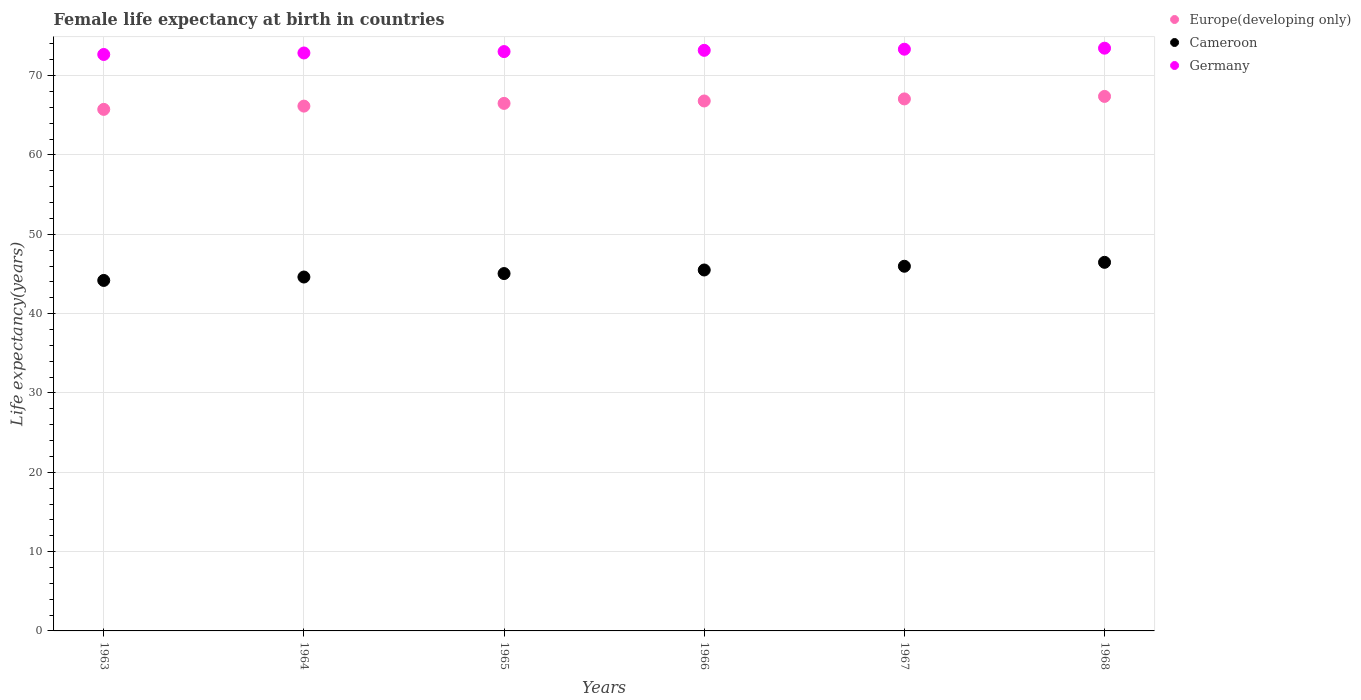Is the number of dotlines equal to the number of legend labels?
Provide a short and direct response. Yes. What is the female life expectancy at birth in Europe(developing only) in 1968?
Make the answer very short. 67.38. Across all years, what is the maximum female life expectancy at birth in Europe(developing only)?
Keep it short and to the point. 67.38. Across all years, what is the minimum female life expectancy at birth in Cameroon?
Give a very brief answer. 44.19. In which year was the female life expectancy at birth in Germany maximum?
Your response must be concise. 1968. In which year was the female life expectancy at birth in Europe(developing only) minimum?
Provide a short and direct response. 1963. What is the total female life expectancy at birth in Europe(developing only) in the graph?
Provide a succinct answer. 399.68. What is the difference between the female life expectancy at birth in Cameroon in 1966 and that in 1968?
Make the answer very short. -0.97. What is the difference between the female life expectancy at birth in Europe(developing only) in 1967 and the female life expectancy at birth in Germany in 1968?
Give a very brief answer. -6.39. What is the average female life expectancy at birth in Germany per year?
Ensure brevity in your answer.  73.09. In the year 1968, what is the difference between the female life expectancy at birth in Cameroon and female life expectancy at birth in Europe(developing only)?
Your answer should be very brief. -20.92. What is the ratio of the female life expectancy at birth in Europe(developing only) in 1963 to that in 1964?
Provide a succinct answer. 0.99. Is the difference between the female life expectancy at birth in Cameroon in 1966 and 1967 greater than the difference between the female life expectancy at birth in Europe(developing only) in 1966 and 1967?
Ensure brevity in your answer.  No. What is the difference between the highest and the second highest female life expectancy at birth in Germany?
Make the answer very short. 0.13. What is the difference between the highest and the lowest female life expectancy at birth in Germany?
Ensure brevity in your answer.  0.79. In how many years, is the female life expectancy at birth in Europe(developing only) greater than the average female life expectancy at birth in Europe(developing only) taken over all years?
Your answer should be very brief. 3. Is the sum of the female life expectancy at birth in Germany in 1963 and 1967 greater than the maximum female life expectancy at birth in Cameroon across all years?
Your response must be concise. Yes. Is the female life expectancy at birth in Germany strictly less than the female life expectancy at birth in Cameroon over the years?
Provide a short and direct response. No. How many dotlines are there?
Keep it short and to the point. 3. How many years are there in the graph?
Keep it short and to the point. 6. What is the difference between two consecutive major ticks on the Y-axis?
Offer a terse response. 10. Does the graph contain any zero values?
Provide a short and direct response. No. Does the graph contain grids?
Keep it short and to the point. Yes. Where does the legend appear in the graph?
Provide a short and direct response. Top right. What is the title of the graph?
Offer a terse response. Female life expectancy at birth in countries. What is the label or title of the Y-axis?
Offer a very short reply. Life expectancy(years). What is the Life expectancy(years) of Europe(developing only) in 1963?
Your answer should be very brief. 65.75. What is the Life expectancy(years) of Cameroon in 1963?
Your answer should be very brief. 44.19. What is the Life expectancy(years) in Germany in 1963?
Your answer should be compact. 72.67. What is the Life expectancy(years) of Europe(developing only) in 1964?
Give a very brief answer. 66.16. What is the Life expectancy(years) of Cameroon in 1964?
Give a very brief answer. 44.62. What is the Life expectancy(years) in Germany in 1964?
Offer a terse response. 72.86. What is the Life expectancy(years) of Europe(developing only) in 1965?
Offer a terse response. 66.51. What is the Life expectancy(years) in Cameroon in 1965?
Provide a succinct answer. 45.05. What is the Life expectancy(years) of Germany in 1965?
Your answer should be compact. 73.04. What is the Life expectancy(years) of Europe(developing only) in 1966?
Give a very brief answer. 66.81. What is the Life expectancy(years) of Cameroon in 1966?
Keep it short and to the point. 45.5. What is the Life expectancy(years) in Germany in 1966?
Make the answer very short. 73.19. What is the Life expectancy(years) in Europe(developing only) in 1967?
Keep it short and to the point. 67.07. What is the Life expectancy(years) in Cameroon in 1967?
Make the answer very short. 45.97. What is the Life expectancy(years) of Germany in 1967?
Give a very brief answer. 73.33. What is the Life expectancy(years) in Europe(developing only) in 1968?
Keep it short and to the point. 67.38. What is the Life expectancy(years) of Cameroon in 1968?
Keep it short and to the point. 46.47. What is the Life expectancy(years) of Germany in 1968?
Provide a succinct answer. 73.46. Across all years, what is the maximum Life expectancy(years) in Europe(developing only)?
Your response must be concise. 67.38. Across all years, what is the maximum Life expectancy(years) of Cameroon?
Your answer should be compact. 46.47. Across all years, what is the maximum Life expectancy(years) in Germany?
Make the answer very short. 73.46. Across all years, what is the minimum Life expectancy(years) of Europe(developing only)?
Keep it short and to the point. 65.75. Across all years, what is the minimum Life expectancy(years) of Cameroon?
Your response must be concise. 44.19. Across all years, what is the minimum Life expectancy(years) in Germany?
Keep it short and to the point. 72.67. What is the total Life expectancy(years) in Europe(developing only) in the graph?
Give a very brief answer. 399.68. What is the total Life expectancy(years) of Cameroon in the graph?
Keep it short and to the point. 271.8. What is the total Life expectancy(years) of Germany in the graph?
Provide a succinct answer. 438.56. What is the difference between the Life expectancy(years) of Europe(developing only) in 1963 and that in 1964?
Give a very brief answer. -0.41. What is the difference between the Life expectancy(years) in Cameroon in 1963 and that in 1964?
Keep it short and to the point. -0.43. What is the difference between the Life expectancy(years) in Germany in 1963 and that in 1964?
Offer a very short reply. -0.19. What is the difference between the Life expectancy(years) in Europe(developing only) in 1963 and that in 1965?
Provide a succinct answer. -0.75. What is the difference between the Life expectancy(years) of Cameroon in 1963 and that in 1965?
Keep it short and to the point. -0.87. What is the difference between the Life expectancy(years) in Germany in 1963 and that in 1965?
Offer a terse response. -0.37. What is the difference between the Life expectancy(years) in Europe(developing only) in 1963 and that in 1966?
Your answer should be compact. -1.06. What is the difference between the Life expectancy(years) in Cameroon in 1963 and that in 1966?
Make the answer very short. -1.32. What is the difference between the Life expectancy(years) of Germany in 1963 and that in 1966?
Provide a succinct answer. -0.52. What is the difference between the Life expectancy(years) of Europe(developing only) in 1963 and that in 1967?
Keep it short and to the point. -1.32. What is the difference between the Life expectancy(years) of Cameroon in 1963 and that in 1967?
Keep it short and to the point. -1.79. What is the difference between the Life expectancy(years) in Germany in 1963 and that in 1967?
Offer a terse response. -0.66. What is the difference between the Life expectancy(years) in Europe(developing only) in 1963 and that in 1968?
Offer a very short reply. -1.63. What is the difference between the Life expectancy(years) in Cameroon in 1963 and that in 1968?
Your answer should be very brief. -2.28. What is the difference between the Life expectancy(years) in Germany in 1963 and that in 1968?
Your answer should be compact. -0.79. What is the difference between the Life expectancy(years) in Europe(developing only) in 1964 and that in 1965?
Provide a succinct answer. -0.34. What is the difference between the Life expectancy(years) of Cameroon in 1964 and that in 1965?
Your answer should be very brief. -0.44. What is the difference between the Life expectancy(years) of Germany in 1964 and that in 1965?
Your answer should be compact. -0.17. What is the difference between the Life expectancy(years) in Europe(developing only) in 1964 and that in 1966?
Your answer should be compact. -0.65. What is the difference between the Life expectancy(years) in Cameroon in 1964 and that in 1966?
Offer a very short reply. -0.89. What is the difference between the Life expectancy(years) of Germany in 1964 and that in 1966?
Give a very brief answer. -0.33. What is the difference between the Life expectancy(years) in Europe(developing only) in 1964 and that in 1967?
Your answer should be very brief. -0.91. What is the difference between the Life expectancy(years) in Cameroon in 1964 and that in 1967?
Offer a very short reply. -1.36. What is the difference between the Life expectancy(years) in Germany in 1964 and that in 1967?
Offer a terse response. -0.47. What is the difference between the Life expectancy(years) in Europe(developing only) in 1964 and that in 1968?
Your response must be concise. -1.22. What is the difference between the Life expectancy(years) in Cameroon in 1964 and that in 1968?
Offer a terse response. -1.85. What is the difference between the Life expectancy(years) of Germany in 1964 and that in 1968?
Your response must be concise. -0.6. What is the difference between the Life expectancy(years) in Europe(developing only) in 1965 and that in 1966?
Give a very brief answer. -0.3. What is the difference between the Life expectancy(years) in Cameroon in 1965 and that in 1966?
Ensure brevity in your answer.  -0.45. What is the difference between the Life expectancy(years) of Germany in 1965 and that in 1966?
Provide a short and direct response. -0.16. What is the difference between the Life expectancy(years) of Europe(developing only) in 1965 and that in 1967?
Offer a terse response. -0.56. What is the difference between the Life expectancy(years) of Cameroon in 1965 and that in 1967?
Offer a very short reply. -0.92. What is the difference between the Life expectancy(years) of Germany in 1965 and that in 1967?
Your response must be concise. -0.3. What is the difference between the Life expectancy(years) in Europe(developing only) in 1965 and that in 1968?
Offer a terse response. -0.88. What is the difference between the Life expectancy(years) in Cameroon in 1965 and that in 1968?
Ensure brevity in your answer.  -1.42. What is the difference between the Life expectancy(years) of Germany in 1965 and that in 1968?
Keep it short and to the point. -0.43. What is the difference between the Life expectancy(years) in Europe(developing only) in 1966 and that in 1967?
Give a very brief answer. -0.26. What is the difference between the Life expectancy(years) in Cameroon in 1966 and that in 1967?
Provide a short and direct response. -0.47. What is the difference between the Life expectancy(years) in Germany in 1966 and that in 1967?
Make the answer very short. -0.14. What is the difference between the Life expectancy(years) in Europe(developing only) in 1966 and that in 1968?
Make the answer very short. -0.58. What is the difference between the Life expectancy(years) of Cameroon in 1966 and that in 1968?
Keep it short and to the point. -0.97. What is the difference between the Life expectancy(years) of Germany in 1966 and that in 1968?
Your answer should be very brief. -0.27. What is the difference between the Life expectancy(years) of Europe(developing only) in 1967 and that in 1968?
Your answer should be very brief. -0.31. What is the difference between the Life expectancy(years) of Cameroon in 1967 and that in 1968?
Provide a short and direct response. -0.49. What is the difference between the Life expectancy(years) in Germany in 1967 and that in 1968?
Provide a succinct answer. -0.13. What is the difference between the Life expectancy(years) in Europe(developing only) in 1963 and the Life expectancy(years) in Cameroon in 1964?
Your answer should be compact. 21.13. What is the difference between the Life expectancy(years) in Europe(developing only) in 1963 and the Life expectancy(years) in Germany in 1964?
Provide a succinct answer. -7.11. What is the difference between the Life expectancy(years) in Cameroon in 1963 and the Life expectancy(years) in Germany in 1964?
Offer a very short reply. -28.68. What is the difference between the Life expectancy(years) of Europe(developing only) in 1963 and the Life expectancy(years) of Cameroon in 1965?
Make the answer very short. 20.7. What is the difference between the Life expectancy(years) of Europe(developing only) in 1963 and the Life expectancy(years) of Germany in 1965?
Offer a very short reply. -7.29. What is the difference between the Life expectancy(years) of Cameroon in 1963 and the Life expectancy(years) of Germany in 1965?
Make the answer very short. -28.85. What is the difference between the Life expectancy(years) in Europe(developing only) in 1963 and the Life expectancy(years) in Cameroon in 1966?
Make the answer very short. 20.25. What is the difference between the Life expectancy(years) of Europe(developing only) in 1963 and the Life expectancy(years) of Germany in 1966?
Provide a short and direct response. -7.44. What is the difference between the Life expectancy(years) of Cameroon in 1963 and the Life expectancy(years) of Germany in 1966?
Provide a succinct answer. -29.01. What is the difference between the Life expectancy(years) in Europe(developing only) in 1963 and the Life expectancy(years) in Cameroon in 1967?
Your answer should be very brief. 19.78. What is the difference between the Life expectancy(years) of Europe(developing only) in 1963 and the Life expectancy(years) of Germany in 1967?
Keep it short and to the point. -7.58. What is the difference between the Life expectancy(years) of Cameroon in 1963 and the Life expectancy(years) of Germany in 1967?
Ensure brevity in your answer.  -29.15. What is the difference between the Life expectancy(years) of Europe(developing only) in 1963 and the Life expectancy(years) of Cameroon in 1968?
Provide a succinct answer. 19.28. What is the difference between the Life expectancy(years) of Europe(developing only) in 1963 and the Life expectancy(years) of Germany in 1968?
Your answer should be very brief. -7.71. What is the difference between the Life expectancy(years) in Cameroon in 1963 and the Life expectancy(years) in Germany in 1968?
Offer a very short reply. -29.28. What is the difference between the Life expectancy(years) of Europe(developing only) in 1964 and the Life expectancy(years) of Cameroon in 1965?
Your response must be concise. 21.11. What is the difference between the Life expectancy(years) in Europe(developing only) in 1964 and the Life expectancy(years) in Germany in 1965?
Ensure brevity in your answer.  -6.87. What is the difference between the Life expectancy(years) in Cameroon in 1964 and the Life expectancy(years) in Germany in 1965?
Make the answer very short. -28.42. What is the difference between the Life expectancy(years) in Europe(developing only) in 1964 and the Life expectancy(years) in Cameroon in 1966?
Offer a very short reply. 20.66. What is the difference between the Life expectancy(years) in Europe(developing only) in 1964 and the Life expectancy(years) in Germany in 1966?
Keep it short and to the point. -7.03. What is the difference between the Life expectancy(years) in Cameroon in 1964 and the Life expectancy(years) in Germany in 1966?
Offer a terse response. -28.58. What is the difference between the Life expectancy(years) in Europe(developing only) in 1964 and the Life expectancy(years) in Cameroon in 1967?
Offer a very short reply. 20.19. What is the difference between the Life expectancy(years) of Europe(developing only) in 1964 and the Life expectancy(years) of Germany in 1967?
Give a very brief answer. -7.17. What is the difference between the Life expectancy(years) in Cameroon in 1964 and the Life expectancy(years) in Germany in 1967?
Keep it short and to the point. -28.72. What is the difference between the Life expectancy(years) in Europe(developing only) in 1964 and the Life expectancy(years) in Cameroon in 1968?
Make the answer very short. 19.69. What is the difference between the Life expectancy(years) of Europe(developing only) in 1964 and the Life expectancy(years) of Germany in 1968?
Offer a terse response. -7.3. What is the difference between the Life expectancy(years) in Cameroon in 1964 and the Life expectancy(years) in Germany in 1968?
Make the answer very short. -28.85. What is the difference between the Life expectancy(years) in Europe(developing only) in 1965 and the Life expectancy(years) in Cameroon in 1966?
Your answer should be compact. 21. What is the difference between the Life expectancy(years) in Europe(developing only) in 1965 and the Life expectancy(years) in Germany in 1966?
Provide a short and direct response. -6.69. What is the difference between the Life expectancy(years) in Cameroon in 1965 and the Life expectancy(years) in Germany in 1966?
Provide a succinct answer. -28.14. What is the difference between the Life expectancy(years) in Europe(developing only) in 1965 and the Life expectancy(years) in Cameroon in 1967?
Make the answer very short. 20.53. What is the difference between the Life expectancy(years) in Europe(developing only) in 1965 and the Life expectancy(years) in Germany in 1967?
Keep it short and to the point. -6.83. What is the difference between the Life expectancy(years) in Cameroon in 1965 and the Life expectancy(years) in Germany in 1967?
Ensure brevity in your answer.  -28.28. What is the difference between the Life expectancy(years) of Europe(developing only) in 1965 and the Life expectancy(years) of Cameroon in 1968?
Make the answer very short. 20.04. What is the difference between the Life expectancy(years) in Europe(developing only) in 1965 and the Life expectancy(years) in Germany in 1968?
Your answer should be very brief. -6.96. What is the difference between the Life expectancy(years) in Cameroon in 1965 and the Life expectancy(years) in Germany in 1968?
Your answer should be compact. -28.41. What is the difference between the Life expectancy(years) in Europe(developing only) in 1966 and the Life expectancy(years) in Cameroon in 1967?
Your response must be concise. 20.84. What is the difference between the Life expectancy(years) in Europe(developing only) in 1966 and the Life expectancy(years) in Germany in 1967?
Offer a very short reply. -6.53. What is the difference between the Life expectancy(years) of Cameroon in 1966 and the Life expectancy(years) of Germany in 1967?
Your response must be concise. -27.83. What is the difference between the Life expectancy(years) in Europe(developing only) in 1966 and the Life expectancy(years) in Cameroon in 1968?
Your answer should be compact. 20.34. What is the difference between the Life expectancy(years) in Europe(developing only) in 1966 and the Life expectancy(years) in Germany in 1968?
Your response must be concise. -6.66. What is the difference between the Life expectancy(years) in Cameroon in 1966 and the Life expectancy(years) in Germany in 1968?
Provide a succinct answer. -27.96. What is the difference between the Life expectancy(years) in Europe(developing only) in 1967 and the Life expectancy(years) in Cameroon in 1968?
Offer a very short reply. 20.6. What is the difference between the Life expectancy(years) of Europe(developing only) in 1967 and the Life expectancy(years) of Germany in 1968?
Offer a very short reply. -6.39. What is the difference between the Life expectancy(years) in Cameroon in 1967 and the Life expectancy(years) in Germany in 1968?
Your response must be concise. -27.49. What is the average Life expectancy(years) of Europe(developing only) per year?
Your answer should be compact. 66.61. What is the average Life expectancy(years) of Cameroon per year?
Give a very brief answer. 45.3. What is the average Life expectancy(years) in Germany per year?
Your answer should be very brief. 73.09. In the year 1963, what is the difference between the Life expectancy(years) in Europe(developing only) and Life expectancy(years) in Cameroon?
Your response must be concise. 21.57. In the year 1963, what is the difference between the Life expectancy(years) in Europe(developing only) and Life expectancy(years) in Germany?
Your response must be concise. -6.92. In the year 1963, what is the difference between the Life expectancy(years) in Cameroon and Life expectancy(years) in Germany?
Ensure brevity in your answer.  -28.48. In the year 1964, what is the difference between the Life expectancy(years) in Europe(developing only) and Life expectancy(years) in Cameroon?
Provide a succinct answer. 21.55. In the year 1964, what is the difference between the Life expectancy(years) in Europe(developing only) and Life expectancy(years) in Germany?
Give a very brief answer. -6.7. In the year 1964, what is the difference between the Life expectancy(years) of Cameroon and Life expectancy(years) of Germany?
Your answer should be very brief. -28.25. In the year 1965, what is the difference between the Life expectancy(years) in Europe(developing only) and Life expectancy(years) in Cameroon?
Keep it short and to the point. 21.45. In the year 1965, what is the difference between the Life expectancy(years) of Europe(developing only) and Life expectancy(years) of Germany?
Offer a very short reply. -6.53. In the year 1965, what is the difference between the Life expectancy(years) in Cameroon and Life expectancy(years) in Germany?
Keep it short and to the point. -27.98. In the year 1966, what is the difference between the Life expectancy(years) in Europe(developing only) and Life expectancy(years) in Cameroon?
Provide a succinct answer. 21.31. In the year 1966, what is the difference between the Life expectancy(years) of Europe(developing only) and Life expectancy(years) of Germany?
Provide a short and direct response. -6.38. In the year 1966, what is the difference between the Life expectancy(years) in Cameroon and Life expectancy(years) in Germany?
Keep it short and to the point. -27.69. In the year 1967, what is the difference between the Life expectancy(years) of Europe(developing only) and Life expectancy(years) of Cameroon?
Your answer should be compact. 21.1. In the year 1967, what is the difference between the Life expectancy(years) of Europe(developing only) and Life expectancy(years) of Germany?
Your answer should be compact. -6.26. In the year 1967, what is the difference between the Life expectancy(years) in Cameroon and Life expectancy(years) in Germany?
Provide a short and direct response. -27.36. In the year 1968, what is the difference between the Life expectancy(years) in Europe(developing only) and Life expectancy(years) in Cameroon?
Give a very brief answer. 20.92. In the year 1968, what is the difference between the Life expectancy(years) in Europe(developing only) and Life expectancy(years) in Germany?
Your response must be concise. -6.08. In the year 1968, what is the difference between the Life expectancy(years) of Cameroon and Life expectancy(years) of Germany?
Keep it short and to the point. -27. What is the ratio of the Life expectancy(years) of Europe(developing only) in 1963 to that in 1964?
Offer a very short reply. 0.99. What is the ratio of the Life expectancy(years) in Cameroon in 1963 to that in 1964?
Provide a succinct answer. 0.99. What is the ratio of the Life expectancy(years) in Europe(developing only) in 1963 to that in 1965?
Make the answer very short. 0.99. What is the ratio of the Life expectancy(years) in Cameroon in 1963 to that in 1965?
Provide a short and direct response. 0.98. What is the ratio of the Life expectancy(years) in Europe(developing only) in 1963 to that in 1966?
Give a very brief answer. 0.98. What is the ratio of the Life expectancy(years) in Cameroon in 1963 to that in 1966?
Your answer should be compact. 0.97. What is the ratio of the Life expectancy(years) in Germany in 1963 to that in 1966?
Ensure brevity in your answer.  0.99. What is the ratio of the Life expectancy(years) of Europe(developing only) in 1963 to that in 1967?
Your response must be concise. 0.98. What is the ratio of the Life expectancy(years) of Cameroon in 1963 to that in 1967?
Keep it short and to the point. 0.96. What is the ratio of the Life expectancy(years) in Germany in 1963 to that in 1967?
Give a very brief answer. 0.99. What is the ratio of the Life expectancy(years) in Europe(developing only) in 1963 to that in 1968?
Give a very brief answer. 0.98. What is the ratio of the Life expectancy(years) of Cameroon in 1963 to that in 1968?
Your response must be concise. 0.95. What is the ratio of the Life expectancy(years) in Germany in 1963 to that in 1968?
Give a very brief answer. 0.99. What is the ratio of the Life expectancy(years) in Europe(developing only) in 1964 to that in 1965?
Provide a succinct answer. 0.99. What is the ratio of the Life expectancy(years) in Cameroon in 1964 to that in 1965?
Offer a terse response. 0.99. What is the ratio of the Life expectancy(years) of Europe(developing only) in 1964 to that in 1966?
Offer a terse response. 0.99. What is the ratio of the Life expectancy(years) in Cameroon in 1964 to that in 1966?
Provide a short and direct response. 0.98. What is the ratio of the Life expectancy(years) in Europe(developing only) in 1964 to that in 1967?
Your answer should be compact. 0.99. What is the ratio of the Life expectancy(years) of Cameroon in 1964 to that in 1967?
Provide a succinct answer. 0.97. What is the ratio of the Life expectancy(years) of Germany in 1964 to that in 1967?
Ensure brevity in your answer.  0.99. What is the ratio of the Life expectancy(years) in Europe(developing only) in 1964 to that in 1968?
Provide a succinct answer. 0.98. What is the ratio of the Life expectancy(years) in Cameroon in 1964 to that in 1968?
Your response must be concise. 0.96. What is the ratio of the Life expectancy(years) in Cameroon in 1965 to that in 1966?
Offer a terse response. 0.99. What is the ratio of the Life expectancy(years) of Europe(developing only) in 1965 to that in 1967?
Your answer should be compact. 0.99. What is the ratio of the Life expectancy(years) in Cameroon in 1965 to that in 1968?
Your answer should be very brief. 0.97. What is the ratio of the Life expectancy(years) in Germany in 1965 to that in 1968?
Provide a short and direct response. 0.99. What is the ratio of the Life expectancy(years) of Europe(developing only) in 1966 to that in 1967?
Provide a short and direct response. 1. What is the ratio of the Life expectancy(years) of Germany in 1966 to that in 1967?
Provide a succinct answer. 1. What is the ratio of the Life expectancy(years) in Cameroon in 1966 to that in 1968?
Ensure brevity in your answer.  0.98. What is the ratio of the Life expectancy(years) of Europe(developing only) in 1967 to that in 1968?
Make the answer very short. 1. What is the ratio of the Life expectancy(years) of Cameroon in 1967 to that in 1968?
Offer a very short reply. 0.99. What is the difference between the highest and the second highest Life expectancy(years) in Europe(developing only)?
Give a very brief answer. 0.31. What is the difference between the highest and the second highest Life expectancy(years) in Cameroon?
Ensure brevity in your answer.  0.49. What is the difference between the highest and the second highest Life expectancy(years) in Germany?
Make the answer very short. 0.13. What is the difference between the highest and the lowest Life expectancy(years) in Europe(developing only)?
Make the answer very short. 1.63. What is the difference between the highest and the lowest Life expectancy(years) of Cameroon?
Offer a very short reply. 2.28. What is the difference between the highest and the lowest Life expectancy(years) in Germany?
Provide a succinct answer. 0.79. 